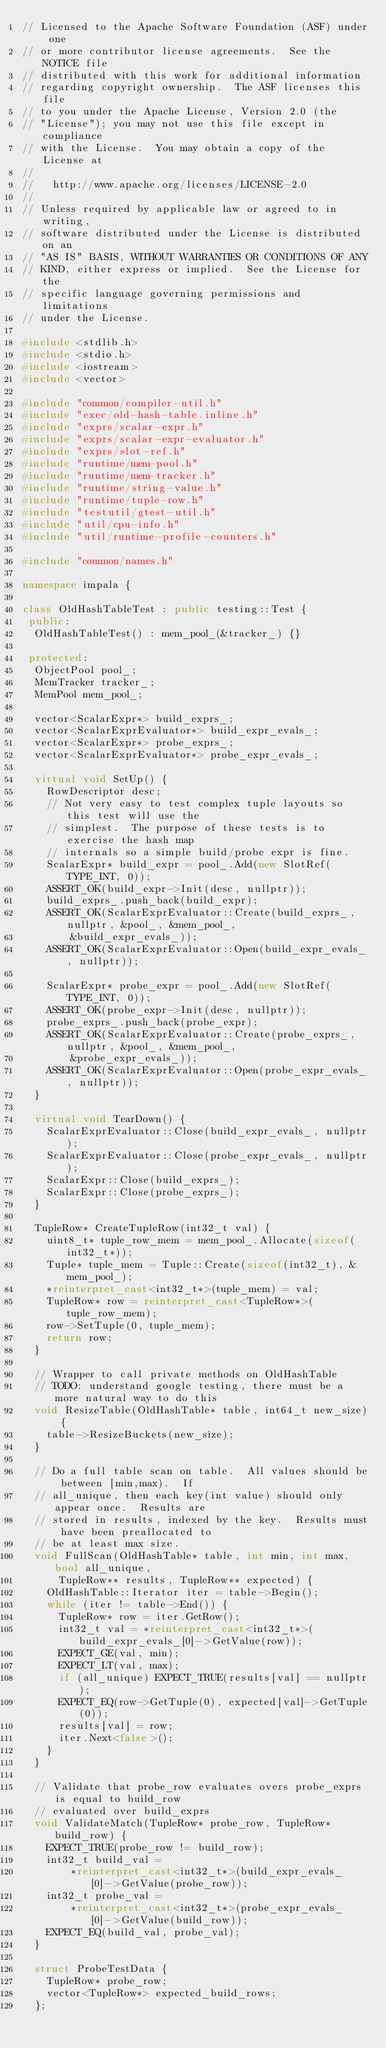Convert code to text. <code><loc_0><loc_0><loc_500><loc_500><_C++_>// Licensed to the Apache Software Foundation (ASF) under one
// or more contributor license agreements.  See the NOTICE file
// distributed with this work for additional information
// regarding copyright ownership.  The ASF licenses this file
// to you under the Apache License, Version 2.0 (the
// "License"); you may not use this file except in compliance
// with the License.  You may obtain a copy of the License at
//
//   http://www.apache.org/licenses/LICENSE-2.0
//
// Unless required by applicable law or agreed to in writing,
// software distributed under the License is distributed on an
// "AS IS" BASIS, WITHOUT WARRANTIES OR CONDITIONS OF ANY
// KIND, either express or implied.  See the License for the
// specific language governing permissions and limitations
// under the License.

#include <stdlib.h>
#include <stdio.h>
#include <iostream>
#include <vector>

#include "common/compiler-util.h"
#include "exec/old-hash-table.inline.h"
#include "exprs/scalar-expr.h"
#include "exprs/scalar-expr-evaluator.h"
#include "exprs/slot-ref.h"
#include "runtime/mem-pool.h"
#include "runtime/mem-tracker.h"
#include "runtime/string-value.h"
#include "runtime/tuple-row.h"
#include "testutil/gtest-util.h"
#include "util/cpu-info.h"
#include "util/runtime-profile-counters.h"

#include "common/names.h"

namespace impala {

class OldHashTableTest : public testing::Test {
 public:
  OldHashTableTest() : mem_pool_(&tracker_) {}

 protected:
  ObjectPool pool_;
  MemTracker tracker_;
  MemPool mem_pool_;

  vector<ScalarExpr*> build_exprs_;
  vector<ScalarExprEvaluator*> build_expr_evals_;
  vector<ScalarExpr*> probe_exprs_;
  vector<ScalarExprEvaluator*> probe_expr_evals_;

  virtual void SetUp() {
    RowDescriptor desc;
    // Not very easy to test complex tuple layouts so this test will use the
    // simplest.  The purpose of these tests is to exercise the hash map
    // internals so a simple build/probe expr is fine.
    ScalarExpr* build_expr = pool_.Add(new SlotRef(TYPE_INT, 0));
    ASSERT_OK(build_expr->Init(desc, nullptr));
    build_exprs_.push_back(build_expr);
    ASSERT_OK(ScalarExprEvaluator::Create(build_exprs_, nullptr, &pool_, &mem_pool_,
        &build_expr_evals_));
    ASSERT_OK(ScalarExprEvaluator::Open(build_expr_evals_, nullptr));

    ScalarExpr* probe_expr = pool_.Add(new SlotRef(TYPE_INT, 0));
    ASSERT_OK(probe_expr->Init(desc, nullptr));
    probe_exprs_.push_back(probe_expr);
    ASSERT_OK(ScalarExprEvaluator::Create(probe_exprs_, nullptr, &pool_, &mem_pool_,
        &probe_expr_evals_));
    ASSERT_OK(ScalarExprEvaluator::Open(probe_expr_evals_, nullptr));
  }

  virtual void TearDown() {
    ScalarExprEvaluator::Close(build_expr_evals_, nullptr);
    ScalarExprEvaluator::Close(probe_expr_evals_, nullptr);
    ScalarExpr::Close(build_exprs_);
    ScalarExpr::Close(probe_exprs_);
  }

  TupleRow* CreateTupleRow(int32_t val) {
    uint8_t* tuple_row_mem = mem_pool_.Allocate(sizeof(int32_t*));
    Tuple* tuple_mem = Tuple::Create(sizeof(int32_t), &mem_pool_);
    *reinterpret_cast<int32_t*>(tuple_mem) = val;
    TupleRow* row = reinterpret_cast<TupleRow*>(tuple_row_mem);
    row->SetTuple(0, tuple_mem);
    return row;
  }

  // Wrapper to call private methods on OldHashTable
  // TODO: understand google testing, there must be a more natural way to do this
  void ResizeTable(OldHashTable* table, int64_t new_size) {
    table->ResizeBuckets(new_size);
  }

  // Do a full table scan on table.  All values should be between [min,max).  If
  // all_unique, then each key(int value) should only appear once.  Results are
  // stored in results, indexed by the key.  Results must have been preallocated to
  // be at least max size.
  void FullScan(OldHashTable* table, int min, int max, bool all_unique,
      TupleRow** results, TupleRow** expected) {
    OldHashTable::Iterator iter = table->Begin();
    while (iter != table->End()) {
      TupleRow* row = iter.GetRow();
      int32_t val = *reinterpret_cast<int32_t*>(build_expr_evals_[0]->GetValue(row));
      EXPECT_GE(val, min);
      EXPECT_LT(val, max);
      if (all_unique) EXPECT_TRUE(results[val] == nullptr);
      EXPECT_EQ(row->GetTuple(0), expected[val]->GetTuple(0));
      results[val] = row;
      iter.Next<false>();
    }
  }

  // Validate that probe_row evaluates overs probe_exprs is equal to build_row
  // evaluated over build_exprs
  void ValidateMatch(TupleRow* probe_row, TupleRow* build_row) {
    EXPECT_TRUE(probe_row != build_row);
    int32_t build_val =
        *reinterpret_cast<int32_t*>(build_expr_evals_[0]->GetValue(probe_row));
    int32_t probe_val =
        *reinterpret_cast<int32_t*>(probe_expr_evals_[0]->GetValue(build_row));
    EXPECT_EQ(build_val, probe_val);
  }

  struct ProbeTestData {
    TupleRow* probe_row;
    vector<TupleRow*> expected_build_rows;
  };
</code> 